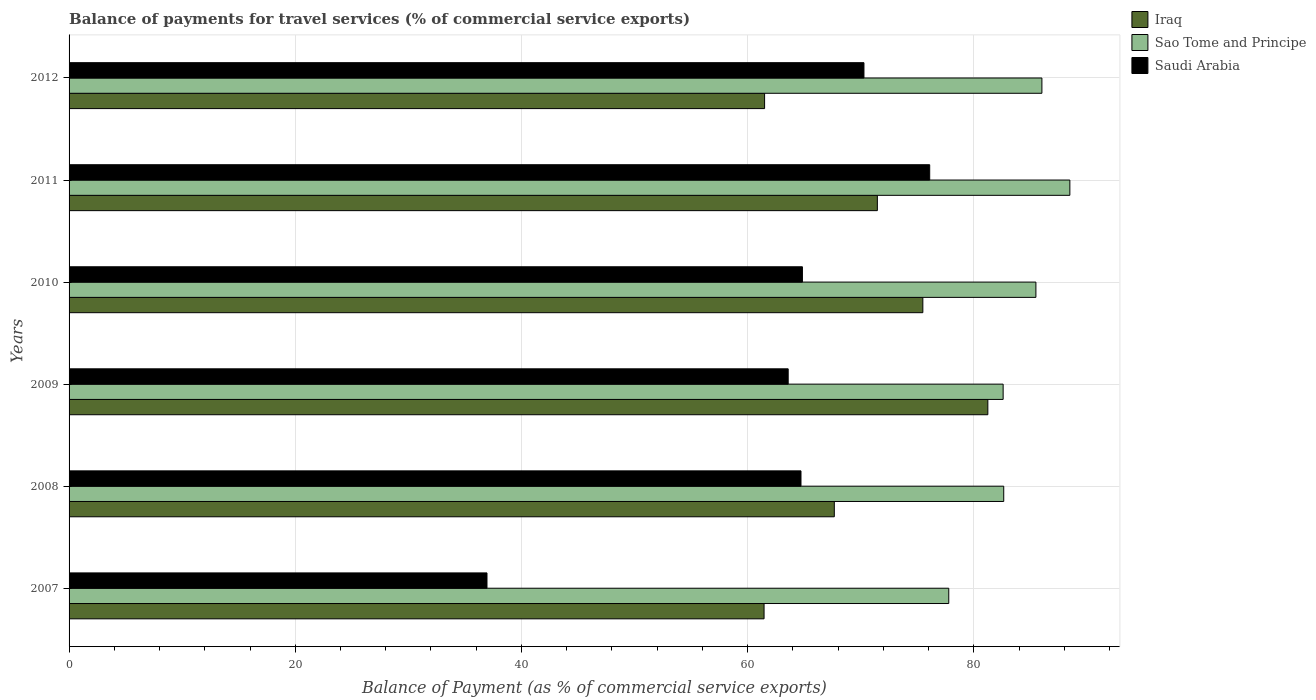How many bars are there on the 6th tick from the bottom?
Your response must be concise. 3. What is the label of the 5th group of bars from the top?
Make the answer very short. 2008. In how many cases, is the number of bars for a given year not equal to the number of legend labels?
Your answer should be compact. 0. What is the balance of payments for travel services in Iraq in 2009?
Keep it short and to the point. 81.24. Across all years, what is the maximum balance of payments for travel services in Saudi Arabia?
Provide a succinct answer. 76.1. Across all years, what is the minimum balance of payments for travel services in Sao Tome and Principe?
Ensure brevity in your answer.  77.78. In which year was the balance of payments for travel services in Sao Tome and Principe maximum?
Make the answer very short. 2011. What is the total balance of payments for travel services in Saudi Arabia in the graph?
Offer a very short reply. 376.47. What is the difference between the balance of payments for travel services in Iraq in 2008 and that in 2011?
Ensure brevity in your answer.  -3.81. What is the difference between the balance of payments for travel services in Sao Tome and Principe in 2011 and the balance of payments for travel services in Saudi Arabia in 2008?
Make the answer very short. 23.77. What is the average balance of payments for travel services in Saudi Arabia per year?
Make the answer very short. 62.75. In the year 2012, what is the difference between the balance of payments for travel services in Sao Tome and Principe and balance of payments for travel services in Iraq?
Provide a succinct answer. 24.52. What is the ratio of the balance of payments for travel services in Sao Tome and Principe in 2009 to that in 2011?
Ensure brevity in your answer.  0.93. Is the balance of payments for travel services in Saudi Arabia in 2007 less than that in 2008?
Provide a succinct answer. Yes. What is the difference between the highest and the second highest balance of payments for travel services in Sao Tome and Principe?
Offer a very short reply. 2.47. What is the difference between the highest and the lowest balance of payments for travel services in Saudi Arabia?
Provide a succinct answer. 39.15. Is the sum of the balance of payments for travel services in Sao Tome and Principe in 2010 and 2011 greater than the maximum balance of payments for travel services in Iraq across all years?
Your answer should be very brief. Yes. What does the 3rd bar from the top in 2011 represents?
Give a very brief answer. Iraq. What does the 2nd bar from the bottom in 2011 represents?
Give a very brief answer. Sao Tome and Principe. How many bars are there?
Keep it short and to the point. 18. Are all the bars in the graph horizontal?
Your answer should be very brief. Yes. What is the difference between two consecutive major ticks on the X-axis?
Offer a very short reply. 20. Does the graph contain any zero values?
Your response must be concise. No. Where does the legend appear in the graph?
Give a very brief answer. Top right. How many legend labels are there?
Offer a terse response. 3. How are the legend labels stacked?
Your response must be concise. Vertical. What is the title of the graph?
Keep it short and to the point. Balance of payments for travel services (% of commercial service exports). What is the label or title of the X-axis?
Make the answer very short. Balance of Payment (as % of commercial service exports). What is the label or title of the Y-axis?
Make the answer very short. Years. What is the Balance of Payment (as % of commercial service exports) in Iraq in 2007?
Offer a terse response. 61.45. What is the Balance of Payment (as % of commercial service exports) of Sao Tome and Principe in 2007?
Your response must be concise. 77.78. What is the Balance of Payment (as % of commercial service exports) of Saudi Arabia in 2007?
Ensure brevity in your answer.  36.95. What is the Balance of Payment (as % of commercial service exports) in Iraq in 2008?
Give a very brief answer. 67.66. What is the Balance of Payment (as % of commercial service exports) of Sao Tome and Principe in 2008?
Ensure brevity in your answer.  82.64. What is the Balance of Payment (as % of commercial service exports) in Saudi Arabia in 2008?
Ensure brevity in your answer.  64.72. What is the Balance of Payment (as % of commercial service exports) in Iraq in 2009?
Your answer should be compact. 81.24. What is the Balance of Payment (as % of commercial service exports) in Sao Tome and Principe in 2009?
Give a very brief answer. 82.59. What is the Balance of Payment (as % of commercial service exports) in Saudi Arabia in 2009?
Offer a terse response. 63.58. What is the Balance of Payment (as % of commercial service exports) in Iraq in 2010?
Offer a terse response. 75.49. What is the Balance of Payment (as % of commercial service exports) of Sao Tome and Principe in 2010?
Keep it short and to the point. 85.49. What is the Balance of Payment (as % of commercial service exports) in Saudi Arabia in 2010?
Your answer should be compact. 64.84. What is the Balance of Payment (as % of commercial service exports) in Iraq in 2011?
Your response must be concise. 71.47. What is the Balance of Payment (as % of commercial service exports) in Sao Tome and Principe in 2011?
Provide a succinct answer. 88.49. What is the Balance of Payment (as % of commercial service exports) of Saudi Arabia in 2011?
Make the answer very short. 76.1. What is the Balance of Payment (as % of commercial service exports) of Iraq in 2012?
Give a very brief answer. 61.5. What is the Balance of Payment (as % of commercial service exports) in Sao Tome and Principe in 2012?
Provide a succinct answer. 86.02. What is the Balance of Payment (as % of commercial service exports) of Saudi Arabia in 2012?
Keep it short and to the point. 70.28. Across all years, what is the maximum Balance of Payment (as % of commercial service exports) of Iraq?
Provide a short and direct response. 81.24. Across all years, what is the maximum Balance of Payment (as % of commercial service exports) in Sao Tome and Principe?
Your response must be concise. 88.49. Across all years, what is the maximum Balance of Payment (as % of commercial service exports) of Saudi Arabia?
Ensure brevity in your answer.  76.1. Across all years, what is the minimum Balance of Payment (as % of commercial service exports) of Iraq?
Offer a terse response. 61.45. Across all years, what is the minimum Balance of Payment (as % of commercial service exports) of Sao Tome and Principe?
Provide a short and direct response. 77.78. Across all years, what is the minimum Balance of Payment (as % of commercial service exports) in Saudi Arabia?
Offer a terse response. 36.95. What is the total Balance of Payment (as % of commercial service exports) in Iraq in the graph?
Offer a very short reply. 418.81. What is the total Balance of Payment (as % of commercial service exports) of Sao Tome and Principe in the graph?
Give a very brief answer. 503.01. What is the total Balance of Payment (as % of commercial service exports) of Saudi Arabia in the graph?
Your response must be concise. 376.47. What is the difference between the Balance of Payment (as % of commercial service exports) in Iraq in 2007 and that in 2008?
Make the answer very short. -6.21. What is the difference between the Balance of Payment (as % of commercial service exports) in Sao Tome and Principe in 2007 and that in 2008?
Provide a short and direct response. -4.86. What is the difference between the Balance of Payment (as % of commercial service exports) of Saudi Arabia in 2007 and that in 2008?
Give a very brief answer. -27.76. What is the difference between the Balance of Payment (as % of commercial service exports) of Iraq in 2007 and that in 2009?
Your response must be concise. -19.79. What is the difference between the Balance of Payment (as % of commercial service exports) in Sao Tome and Principe in 2007 and that in 2009?
Offer a terse response. -4.81. What is the difference between the Balance of Payment (as % of commercial service exports) of Saudi Arabia in 2007 and that in 2009?
Your response must be concise. -26.63. What is the difference between the Balance of Payment (as % of commercial service exports) in Iraq in 2007 and that in 2010?
Ensure brevity in your answer.  -14.04. What is the difference between the Balance of Payment (as % of commercial service exports) of Sao Tome and Principe in 2007 and that in 2010?
Offer a very short reply. -7.7. What is the difference between the Balance of Payment (as % of commercial service exports) of Saudi Arabia in 2007 and that in 2010?
Make the answer very short. -27.89. What is the difference between the Balance of Payment (as % of commercial service exports) in Iraq in 2007 and that in 2011?
Your answer should be very brief. -10.02. What is the difference between the Balance of Payment (as % of commercial service exports) in Sao Tome and Principe in 2007 and that in 2011?
Your answer should be very brief. -10.71. What is the difference between the Balance of Payment (as % of commercial service exports) of Saudi Arabia in 2007 and that in 2011?
Your response must be concise. -39.15. What is the difference between the Balance of Payment (as % of commercial service exports) in Iraq in 2007 and that in 2012?
Provide a short and direct response. -0.05. What is the difference between the Balance of Payment (as % of commercial service exports) of Sao Tome and Principe in 2007 and that in 2012?
Your response must be concise. -8.23. What is the difference between the Balance of Payment (as % of commercial service exports) in Saudi Arabia in 2007 and that in 2012?
Make the answer very short. -33.33. What is the difference between the Balance of Payment (as % of commercial service exports) of Iraq in 2008 and that in 2009?
Provide a succinct answer. -13.57. What is the difference between the Balance of Payment (as % of commercial service exports) in Sao Tome and Principe in 2008 and that in 2009?
Offer a very short reply. 0.05. What is the difference between the Balance of Payment (as % of commercial service exports) in Saudi Arabia in 2008 and that in 2009?
Provide a succinct answer. 1.13. What is the difference between the Balance of Payment (as % of commercial service exports) of Iraq in 2008 and that in 2010?
Provide a short and direct response. -7.83. What is the difference between the Balance of Payment (as % of commercial service exports) in Sao Tome and Principe in 2008 and that in 2010?
Provide a succinct answer. -2.84. What is the difference between the Balance of Payment (as % of commercial service exports) in Saudi Arabia in 2008 and that in 2010?
Keep it short and to the point. -0.13. What is the difference between the Balance of Payment (as % of commercial service exports) of Iraq in 2008 and that in 2011?
Provide a succinct answer. -3.81. What is the difference between the Balance of Payment (as % of commercial service exports) of Sao Tome and Principe in 2008 and that in 2011?
Keep it short and to the point. -5.85. What is the difference between the Balance of Payment (as % of commercial service exports) in Saudi Arabia in 2008 and that in 2011?
Keep it short and to the point. -11.38. What is the difference between the Balance of Payment (as % of commercial service exports) in Iraq in 2008 and that in 2012?
Offer a terse response. 6.16. What is the difference between the Balance of Payment (as % of commercial service exports) in Sao Tome and Principe in 2008 and that in 2012?
Provide a succinct answer. -3.37. What is the difference between the Balance of Payment (as % of commercial service exports) in Saudi Arabia in 2008 and that in 2012?
Provide a succinct answer. -5.57. What is the difference between the Balance of Payment (as % of commercial service exports) of Iraq in 2009 and that in 2010?
Offer a very short reply. 5.75. What is the difference between the Balance of Payment (as % of commercial service exports) of Sao Tome and Principe in 2009 and that in 2010?
Provide a short and direct response. -2.9. What is the difference between the Balance of Payment (as % of commercial service exports) of Saudi Arabia in 2009 and that in 2010?
Your answer should be compact. -1.26. What is the difference between the Balance of Payment (as % of commercial service exports) in Iraq in 2009 and that in 2011?
Offer a terse response. 9.77. What is the difference between the Balance of Payment (as % of commercial service exports) in Sao Tome and Principe in 2009 and that in 2011?
Give a very brief answer. -5.9. What is the difference between the Balance of Payment (as % of commercial service exports) of Saudi Arabia in 2009 and that in 2011?
Ensure brevity in your answer.  -12.51. What is the difference between the Balance of Payment (as % of commercial service exports) of Iraq in 2009 and that in 2012?
Your answer should be very brief. 19.74. What is the difference between the Balance of Payment (as % of commercial service exports) of Sao Tome and Principe in 2009 and that in 2012?
Make the answer very short. -3.43. What is the difference between the Balance of Payment (as % of commercial service exports) of Saudi Arabia in 2009 and that in 2012?
Ensure brevity in your answer.  -6.7. What is the difference between the Balance of Payment (as % of commercial service exports) of Iraq in 2010 and that in 2011?
Offer a terse response. 4.02. What is the difference between the Balance of Payment (as % of commercial service exports) in Sao Tome and Principe in 2010 and that in 2011?
Provide a short and direct response. -3. What is the difference between the Balance of Payment (as % of commercial service exports) of Saudi Arabia in 2010 and that in 2011?
Keep it short and to the point. -11.25. What is the difference between the Balance of Payment (as % of commercial service exports) of Iraq in 2010 and that in 2012?
Provide a succinct answer. 13.99. What is the difference between the Balance of Payment (as % of commercial service exports) of Sao Tome and Principe in 2010 and that in 2012?
Your answer should be very brief. -0.53. What is the difference between the Balance of Payment (as % of commercial service exports) in Saudi Arabia in 2010 and that in 2012?
Offer a very short reply. -5.44. What is the difference between the Balance of Payment (as % of commercial service exports) in Iraq in 2011 and that in 2012?
Your answer should be compact. 9.97. What is the difference between the Balance of Payment (as % of commercial service exports) of Sao Tome and Principe in 2011 and that in 2012?
Your answer should be very brief. 2.47. What is the difference between the Balance of Payment (as % of commercial service exports) in Saudi Arabia in 2011 and that in 2012?
Provide a short and direct response. 5.81. What is the difference between the Balance of Payment (as % of commercial service exports) of Iraq in 2007 and the Balance of Payment (as % of commercial service exports) of Sao Tome and Principe in 2008?
Provide a succinct answer. -21.19. What is the difference between the Balance of Payment (as % of commercial service exports) of Iraq in 2007 and the Balance of Payment (as % of commercial service exports) of Saudi Arabia in 2008?
Offer a terse response. -3.26. What is the difference between the Balance of Payment (as % of commercial service exports) in Sao Tome and Principe in 2007 and the Balance of Payment (as % of commercial service exports) in Saudi Arabia in 2008?
Ensure brevity in your answer.  13.07. What is the difference between the Balance of Payment (as % of commercial service exports) of Iraq in 2007 and the Balance of Payment (as % of commercial service exports) of Sao Tome and Principe in 2009?
Offer a very short reply. -21.14. What is the difference between the Balance of Payment (as % of commercial service exports) of Iraq in 2007 and the Balance of Payment (as % of commercial service exports) of Saudi Arabia in 2009?
Keep it short and to the point. -2.13. What is the difference between the Balance of Payment (as % of commercial service exports) of Sao Tome and Principe in 2007 and the Balance of Payment (as % of commercial service exports) of Saudi Arabia in 2009?
Make the answer very short. 14.2. What is the difference between the Balance of Payment (as % of commercial service exports) in Iraq in 2007 and the Balance of Payment (as % of commercial service exports) in Sao Tome and Principe in 2010?
Offer a very short reply. -24.04. What is the difference between the Balance of Payment (as % of commercial service exports) of Iraq in 2007 and the Balance of Payment (as % of commercial service exports) of Saudi Arabia in 2010?
Make the answer very short. -3.39. What is the difference between the Balance of Payment (as % of commercial service exports) in Sao Tome and Principe in 2007 and the Balance of Payment (as % of commercial service exports) in Saudi Arabia in 2010?
Offer a terse response. 12.94. What is the difference between the Balance of Payment (as % of commercial service exports) of Iraq in 2007 and the Balance of Payment (as % of commercial service exports) of Sao Tome and Principe in 2011?
Your answer should be compact. -27.04. What is the difference between the Balance of Payment (as % of commercial service exports) of Iraq in 2007 and the Balance of Payment (as % of commercial service exports) of Saudi Arabia in 2011?
Your response must be concise. -14.65. What is the difference between the Balance of Payment (as % of commercial service exports) of Sao Tome and Principe in 2007 and the Balance of Payment (as % of commercial service exports) of Saudi Arabia in 2011?
Provide a short and direct response. 1.69. What is the difference between the Balance of Payment (as % of commercial service exports) of Iraq in 2007 and the Balance of Payment (as % of commercial service exports) of Sao Tome and Principe in 2012?
Give a very brief answer. -24.57. What is the difference between the Balance of Payment (as % of commercial service exports) of Iraq in 2007 and the Balance of Payment (as % of commercial service exports) of Saudi Arabia in 2012?
Provide a short and direct response. -8.83. What is the difference between the Balance of Payment (as % of commercial service exports) of Sao Tome and Principe in 2007 and the Balance of Payment (as % of commercial service exports) of Saudi Arabia in 2012?
Your response must be concise. 7.5. What is the difference between the Balance of Payment (as % of commercial service exports) of Iraq in 2008 and the Balance of Payment (as % of commercial service exports) of Sao Tome and Principe in 2009?
Give a very brief answer. -14.93. What is the difference between the Balance of Payment (as % of commercial service exports) in Iraq in 2008 and the Balance of Payment (as % of commercial service exports) in Saudi Arabia in 2009?
Your response must be concise. 4.08. What is the difference between the Balance of Payment (as % of commercial service exports) in Sao Tome and Principe in 2008 and the Balance of Payment (as % of commercial service exports) in Saudi Arabia in 2009?
Offer a terse response. 19.06. What is the difference between the Balance of Payment (as % of commercial service exports) in Iraq in 2008 and the Balance of Payment (as % of commercial service exports) in Sao Tome and Principe in 2010?
Your response must be concise. -17.83. What is the difference between the Balance of Payment (as % of commercial service exports) in Iraq in 2008 and the Balance of Payment (as % of commercial service exports) in Saudi Arabia in 2010?
Give a very brief answer. 2.82. What is the difference between the Balance of Payment (as % of commercial service exports) in Iraq in 2008 and the Balance of Payment (as % of commercial service exports) in Sao Tome and Principe in 2011?
Offer a very short reply. -20.83. What is the difference between the Balance of Payment (as % of commercial service exports) of Iraq in 2008 and the Balance of Payment (as % of commercial service exports) of Saudi Arabia in 2011?
Provide a succinct answer. -8.44. What is the difference between the Balance of Payment (as % of commercial service exports) of Sao Tome and Principe in 2008 and the Balance of Payment (as % of commercial service exports) of Saudi Arabia in 2011?
Offer a terse response. 6.55. What is the difference between the Balance of Payment (as % of commercial service exports) in Iraq in 2008 and the Balance of Payment (as % of commercial service exports) in Sao Tome and Principe in 2012?
Your response must be concise. -18.36. What is the difference between the Balance of Payment (as % of commercial service exports) of Iraq in 2008 and the Balance of Payment (as % of commercial service exports) of Saudi Arabia in 2012?
Your response must be concise. -2.62. What is the difference between the Balance of Payment (as % of commercial service exports) of Sao Tome and Principe in 2008 and the Balance of Payment (as % of commercial service exports) of Saudi Arabia in 2012?
Offer a very short reply. 12.36. What is the difference between the Balance of Payment (as % of commercial service exports) of Iraq in 2009 and the Balance of Payment (as % of commercial service exports) of Sao Tome and Principe in 2010?
Give a very brief answer. -4.25. What is the difference between the Balance of Payment (as % of commercial service exports) in Iraq in 2009 and the Balance of Payment (as % of commercial service exports) in Saudi Arabia in 2010?
Provide a short and direct response. 16.39. What is the difference between the Balance of Payment (as % of commercial service exports) of Sao Tome and Principe in 2009 and the Balance of Payment (as % of commercial service exports) of Saudi Arabia in 2010?
Your response must be concise. 17.75. What is the difference between the Balance of Payment (as % of commercial service exports) in Iraq in 2009 and the Balance of Payment (as % of commercial service exports) in Sao Tome and Principe in 2011?
Offer a terse response. -7.25. What is the difference between the Balance of Payment (as % of commercial service exports) of Iraq in 2009 and the Balance of Payment (as % of commercial service exports) of Saudi Arabia in 2011?
Make the answer very short. 5.14. What is the difference between the Balance of Payment (as % of commercial service exports) in Sao Tome and Principe in 2009 and the Balance of Payment (as % of commercial service exports) in Saudi Arabia in 2011?
Provide a short and direct response. 6.49. What is the difference between the Balance of Payment (as % of commercial service exports) in Iraq in 2009 and the Balance of Payment (as % of commercial service exports) in Sao Tome and Principe in 2012?
Your response must be concise. -4.78. What is the difference between the Balance of Payment (as % of commercial service exports) of Iraq in 2009 and the Balance of Payment (as % of commercial service exports) of Saudi Arabia in 2012?
Offer a very short reply. 10.95. What is the difference between the Balance of Payment (as % of commercial service exports) of Sao Tome and Principe in 2009 and the Balance of Payment (as % of commercial service exports) of Saudi Arabia in 2012?
Make the answer very short. 12.31. What is the difference between the Balance of Payment (as % of commercial service exports) of Iraq in 2010 and the Balance of Payment (as % of commercial service exports) of Sao Tome and Principe in 2011?
Provide a short and direct response. -13. What is the difference between the Balance of Payment (as % of commercial service exports) in Iraq in 2010 and the Balance of Payment (as % of commercial service exports) in Saudi Arabia in 2011?
Provide a short and direct response. -0.61. What is the difference between the Balance of Payment (as % of commercial service exports) in Sao Tome and Principe in 2010 and the Balance of Payment (as % of commercial service exports) in Saudi Arabia in 2011?
Offer a very short reply. 9.39. What is the difference between the Balance of Payment (as % of commercial service exports) of Iraq in 2010 and the Balance of Payment (as % of commercial service exports) of Sao Tome and Principe in 2012?
Offer a terse response. -10.53. What is the difference between the Balance of Payment (as % of commercial service exports) of Iraq in 2010 and the Balance of Payment (as % of commercial service exports) of Saudi Arabia in 2012?
Your answer should be compact. 5.21. What is the difference between the Balance of Payment (as % of commercial service exports) of Sao Tome and Principe in 2010 and the Balance of Payment (as % of commercial service exports) of Saudi Arabia in 2012?
Your answer should be very brief. 15.2. What is the difference between the Balance of Payment (as % of commercial service exports) in Iraq in 2011 and the Balance of Payment (as % of commercial service exports) in Sao Tome and Principe in 2012?
Offer a terse response. -14.55. What is the difference between the Balance of Payment (as % of commercial service exports) in Iraq in 2011 and the Balance of Payment (as % of commercial service exports) in Saudi Arabia in 2012?
Provide a short and direct response. 1.18. What is the difference between the Balance of Payment (as % of commercial service exports) of Sao Tome and Principe in 2011 and the Balance of Payment (as % of commercial service exports) of Saudi Arabia in 2012?
Your answer should be very brief. 18.21. What is the average Balance of Payment (as % of commercial service exports) of Iraq per year?
Your answer should be compact. 69.8. What is the average Balance of Payment (as % of commercial service exports) of Sao Tome and Principe per year?
Offer a terse response. 83.83. What is the average Balance of Payment (as % of commercial service exports) in Saudi Arabia per year?
Provide a short and direct response. 62.75. In the year 2007, what is the difference between the Balance of Payment (as % of commercial service exports) in Iraq and Balance of Payment (as % of commercial service exports) in Sao Tome and Principe?
Your answer should be very brief. -16.33. In the year 2007, what is the difference between the Balance of Payment (as % of commercial service exports) of Iraq and Balance of Payment (as % of commercial service exports) of Saudi Arabia?
Keep it short and to the point. 24.5. In the year 2007, what is the difference between the Balance of Payment (as % of commercial service exports) in Sao Tome and Principe and Balance of Payment (as % of commercial service exports) in Saudi Arabia?
Provide a succinct answer. 40.83. In the year 2008, what is the difference between the Balance of Payment (as % of commercial service exports) of Iraq and Balance of Payment (as % of commercial service exports) of Sao Tome and Principe?
Your answer should be very brief. -14.98. In the year 2008, what is the difference between the Balance of Payment (as % of commercial service exports) in Iraq and Balance of Payment (as % of commercial service exports) in Saudi Arabia?
Give a very brief answer. 2.95. In the year 2008, what is the difference between the Balance of Payment (as % of commercial service exports) of Sao Tome and Principe and Balance of Payment (as % of commercial service exports) of Saudi Arabia?
Your response must be concise. 17.93. In the year 2009, what is the difference between the Balance of Payment (as % of commercial service exports) in Iraq and Balance of Payment (as % of commercial service exports) in Sao Tome and Principe?
Ensure brevity in your answer.  -1.35. In the year 2009, what is the difference between the Balance of Payment (as % of commercial service exports) of Iraq and Balance of Payment (as % of commercial service exports) of Saudi Arabia?
Your response must be concise. 17.65. In the year 2009, what is the difference between the Balance of Payment (as % of commercial service exports) of Sao Tome and Principe and Balance of Payment (as % of commercial service exports) of Saudi Arabia?
Offer a terse response. 19.01. In the year 2010, what is the difference between the Balance of Payment (as % of commercial service exports) in Iraq and Balance of Payment (as % of commercial service exports) in Sao Tome and Principe?
Provide a short and direct response. -10. In the year 2010, what is the difference between the Balance of Payment (as % of commercial service exports) of Iraq and Balance of Payment (as % of commercial service exports) of Saudi Arabia?
Offer a very short reply. 10.65. In the year 2010, what is the difference between the Balance of Payment (as % of commercial service exports) in Sao Tome and Principe and Balance of Payment (as % of commercial service exports) in Saudi Arabia?
Your answer should be very brief. 20.64. In the year 2011, what is the difference between the Balance of Payment (as % of commercial service exports) of Iraq and Balance of Payment (as % of commercial service exports) of Sao Tome and Principe?
Make the answer very short. -17.02. In the year 2011, what is the difference between the Balance of Payment (as % of commercial service exports) in Iraq and Balance of Payment (as % of commercial service exports) in Saudi Arabia?
Offer a terse response. -4.63. In the year 2011, what is the difference between the Balance of Payment (as % of commercial service exports) in Sao Tome and Principe and Balance of Payment (as % of commercial service exports) in Saudi Arabia?
Offer a very short reply. 12.39. In the year 2012, what is the difference between the Balance of Payment (as % of commercial service exports) of Iraq and Balance of Payment (as % of commercial service exports) of Sao Tome and Principe?
Provide a succinct answer. -24.52. In the year 2012, what is the difference between the Balance of Payment (as % of commercial service exports) of Iraq and Balance of Payment (as % of commercial service exports) of Saudi Arabia?
Make the answer very short. -8.79. In the year 2012, what is the difference between the Balance of Payment (as % of commercial service exports) in Sao Tome and Principe and Balance of Payment (as % of commercial service exports) in Saudi Arabia?
Offer a very short reply. 15.73. What is the ratio of the Balance of Payment (as % of commercial service exports) of Iraq in 2007 to that in 2008?
Provide a succinct answer. 0.91. What is the ratio of the Balance of Payment (as % of commercial service exports) of Sao Tome and Principe in 2007 to that in 2008?
Give a very brief answer. 0.94. What is the ratio of the Balance of Payment (as % of commercial service exports) of Saudi Arabia in 2007 to that in 2008?
Offer a terse response. 0.57. What is the ratio of the Balance of Payment (as % of commercial service exports) of Iraq in 2007 to that in 2009?
Offer a terse response. 0.76. What is the ratio of the Balance of Payment (as % of commercial service exports) in Sao Tome and Principe in 2007 to that in 2009?
Your answer should be very brief. 0.94. What is the ratio of the Balance of Payment (as % of commercial service exports) of Saudi Arabia in 2007 to that in 2009?
Make the answer very short. 0.58. What is the ratio of the Balance of Payment (as % of commercial service exports) in Iraq in 2007 to that in 2010?
Provide a succinct answer. 0.81. What is the ratio of the Balance of Payment (as % of commercial service exports) in Sao Tome and Principe in 2007 to that in 2010?
Offer a very short reply. 0.91. What is the ratio of the Balance of Payment (as % of commercial service exports) of Saudi Arabia in 2007 to that in 2010?
Provide a succinct answer. 0.57. What is the ratio of the Balance of Payment (as % of commercial service exports) in Iraq in 2007 to that in 2011?
Ensure brevity in your answer.  0.86. What is the ratio of the Balance of Payment (as % of commercial service exports) of Sao Tome and Principe in 2007 to that in 2011?
Make the answer very short. 0.88. What is the ratio of the Balance of Payment (as % of commercial service exports) of Saudi Arabia in 2007 to that in 2011?
Your answer should be very brief. 0.49. What is the ratio of the Balance of Payment (as % of commercial service exports) in Sao Tome and Principe in 2007 to that in 2012?
Give a very brief answer. 0.9. What is the ratio of the Balance of Payment (as % of commercial service exports) of Saudi Arabia in 2007 to that in 2012?
Keep it short and to the point. 0.53. What is the ratio of the Balance of Payment (as % of commercial service exports) in Iraq in 2008 to that in 2009?
Offer a terse response. 0.83. What is the ratio of the Balance of Payment (as % of commercial service exports) of Sao Tome and Principe in 2008 to that in 2009?
Offer a terse response. 1. What is the ratio of the Balance of Payment (as % of commercial service exports) of Saudi Arabia in 2008 to that in 2009?
Make the answer very short. 1.02. What is the ratio of the Balance of Payment (as % of commercial service exports) in Iraq in 2008 to that in 2010?
Offer a very short reply. 0.9. What is the ratio of the Balance of Payment (as % of commercial service exports) in Sao Tome and Principe in 2008 to that in 2010?
Your response must be concise. 0.97. What is the ratio of the Balance of Payment (as % of commercial service exports) of Saudi Arabia in 2008 to that in 2010?
Your answer should be very brief. 1. What is the ratio of the Balance of Payment (as % of commercial service exports) in Iraq in 2008 to that in 2011?
Provide a succinct answer. 0.95. What is the ratio of the Balance of Payment (as % of commercial service exports) of Sao Tome and Principe in 2008 to that in 2011?
Offer a terse response. 0.93. What is the ratio of the Balance of Payment (as % of commercial service exports) in Saudi Arabia in 2008 to that in 2011?
Make the answer very short. 0.85. What is the ratio of the Balance of Payment (as % of commercial service exports) of Iraq in 2008 to that in 2012?
Make the answer very short. 1.1. What is the ratio of the Balance of Payment (as % of commercial service exports) of Sao Tome and Principe in 2008 to that in 2012?
Keep it short and to the point. 0.96. What is the ratio of the Balance of Payment (as % of commercial service exports) of Saudi Arabia in 2008 to that in 2012?
Provide a short and direct response. 0.92. What is the ratio of the Balance of Payment (as % of commercial service exports) in Iraq in 2009 to that in 2010?
Give a very brief answer. 1.08. What is the ratio of the Balance of Payment (as % of commercial service exports) of Sao Tome and Principe in 2009 to that in 2010?
Provide a succinct answer. 0.97. What is the ratio of the Balance of Payment (as % of commercial service exports) in Saudi Arabia in 2009 to that in 2010?
Keep it short and to the point. 0.98. What is the ratio of the Balance of Payment (as % of commercial service exports) in Iraq in 2009 to that in 2011?
Your answer should be very brief. 1.14. What is the ratio of the Balance of Payment (as % of commercial service exports) of Saudi Arabia in 2009 to that in 2011?
Your response must be concise. 0.84. What is the ratio of the Balance of Payment (as % of commercial service exports) of Iraq in 2009 to that in 2012?
Provide a short and direct response. 1.32. What is the ratio of the Balance of Payment (as % of commercial service exports) of Sao Tome and Principe in 2009 to that in 2012?
Ensure brevity in your answer.  0.96. What is the ratio of the Balance of Payment (as % of commercial service exports) of Saudi Arabia in 2009 to that in 2012?
Keep it short and to the point. 0.9. What is the ratio of the Balance of Payment (as % of commercial service exports) of Iraq in 2010 to that in 2011?
Your answer should be very brief. 1.06. What is the ratio of the Balance of Payment (as % of commercial service exports) of Sao Tome and Principe in 2010 to that in 2011?
Offer a very short reply. 0.97. What is the ratio of the Balance of Payment (as % of commercial service exports) in Saudi Arabia in 2010 to that in 2011?
Provide a succinct answer. 0.85. What is the ratio of the Balance of Payment (as % of commercial service exports) in Iraq in 2010 to that in 2012?
Your answer should be very brief. 1.23. What is the ratio of the Balance of Payment (as % of commercial service exports) in Saudi Arabia in 2010 to that in 2012?
Make the answer very short. 0.92. What is the ratio of the Balance of Payment (as % of commercial service exports) of Iraq in 2011 to that in 2012?
Provide a succinct answer. 1.16. What is the ratio of the Balance of Payment (as % of commercial service exports) of Sao Tome and Principe in 2011 to that in 2012?
Your answer should be compact. 1.03. What is the ratio of the Balance of Payment (as % of commercial service exports) in Saudi Arabia in 2011 to that in 2012?
Provide a succinct answer. 1.08. What is the difference between the highest and the second highest Balance of Payment (as % of commercial service exports) in Iraq?
Give a very brief answer. 5.75. What is the difference between the highest and the second highest Balance of Payment (as % of commercial service exports) in Sao Tome and Principe?
Provide a succinct answer. 2.47. What is the difference between the highest and the second highest Balance of Payment (as % of commercial service exports) of Saudi Arabia?
Make the answer very short. 5.81. What is the difference between the highest and the lowest Balance of Payment (as % of commercial service exports) in Iraq?
Your response must be concise. 19.79. What is the difference between the highest and the lowest Balance of Payment (as % of commercial service exports) in Sao Tome and Principe?
Provide a short and direct response. 10.71. What is the difference between the highest and the lowest Balance of Payment (as % of commercial service exports) in Saudi Arabia?
Provide a short and direct response. 39.15. 